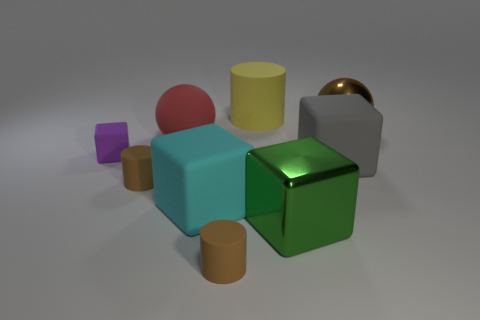Subtract all brown cylinders. How many cylinders are left? 1 Subtract all cylinders. How many objects are left? 6 Subtract 1 balls. How many balls are left? 1 Add 4 red matte objects. How many red matte objects are left? 5 Add 2 big purple cylinders. How many big purple cylinders exist? 2 Add 1 red matte things. How many objects exist? 10 Subtract all cyan cubes. How many cubes are left? 3 Subtract 1 purple blocks. How many objects are left? 8 Subtract all cyan spheres. Subtract all brown cubes. How many spheres are left? 2 Subtract all gray balls. How many brown cylinders are left? 2 